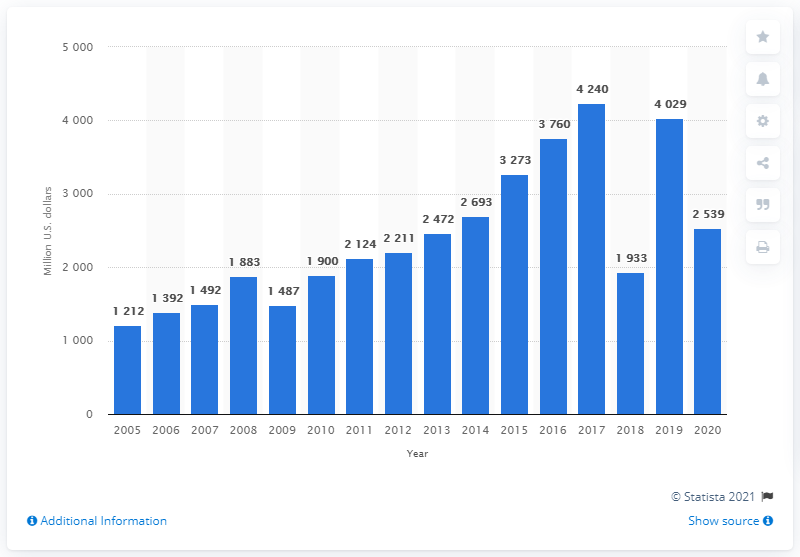Point out several critical features in this image. In 2020, Nike's global net income in dollars was 2539. 